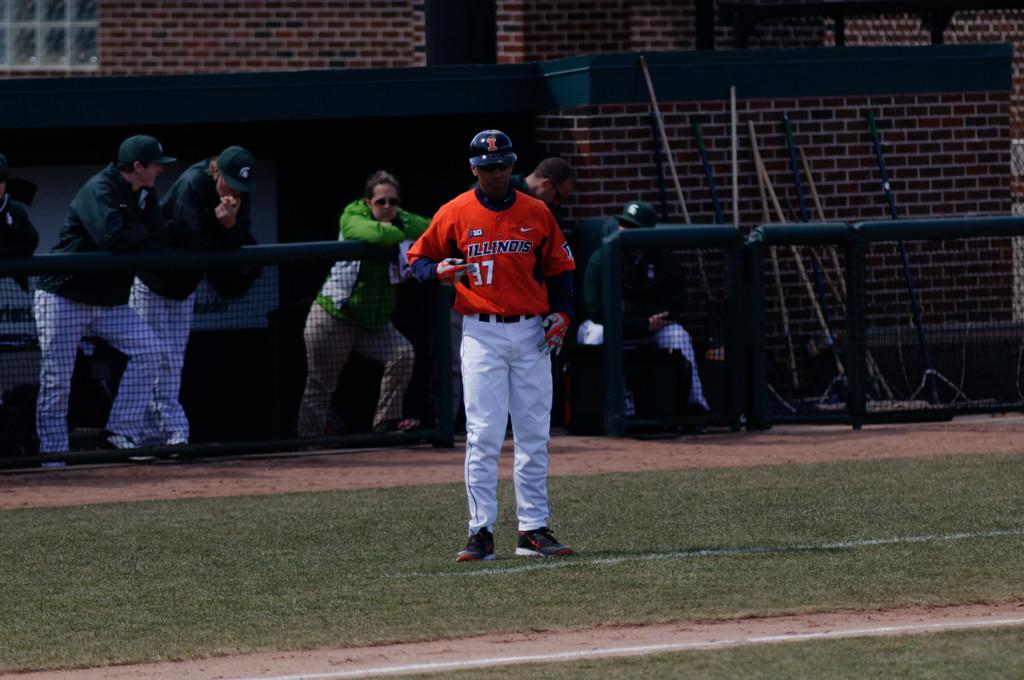<image>
Create a compact narrative representing the image presented. a man that is wearing an Illinois baseball jersey 